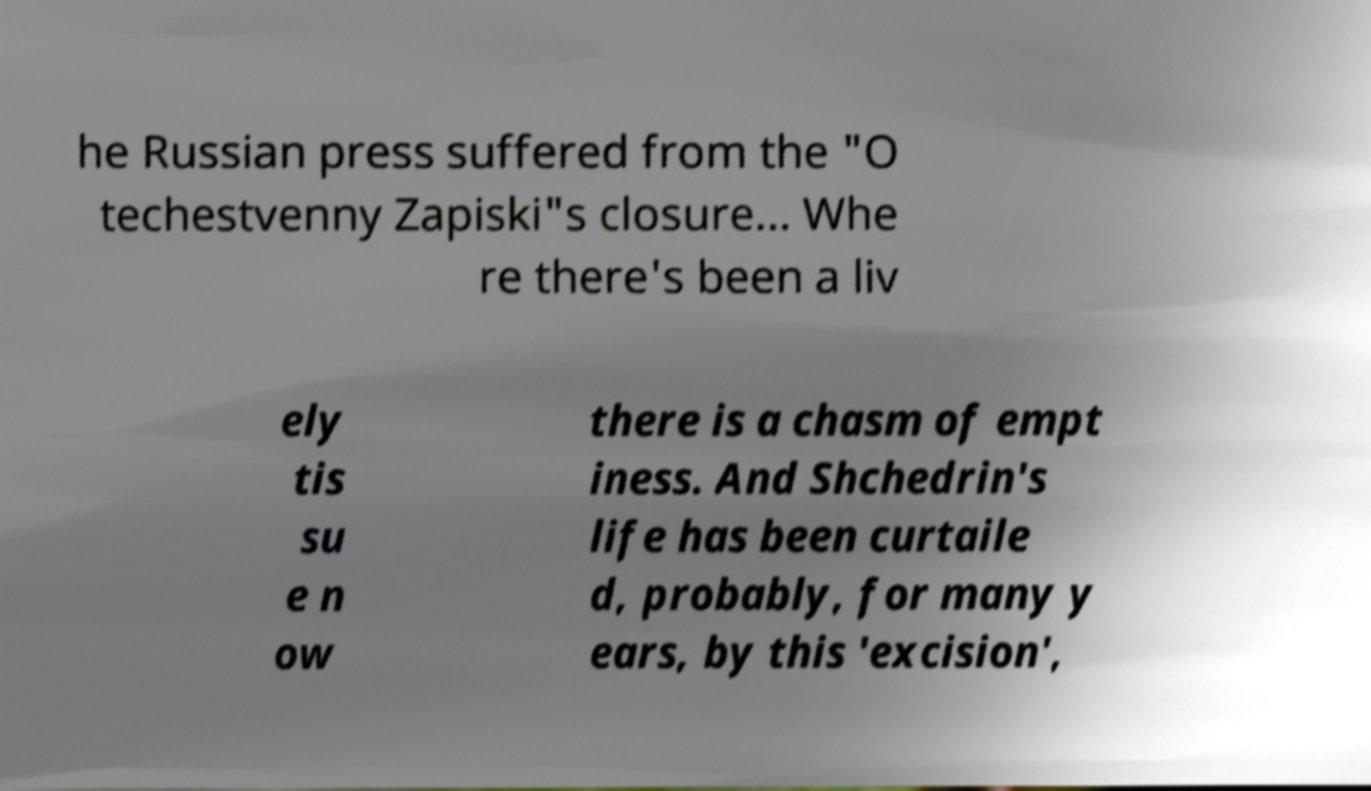For documentation purposes, I need the text within this image transcribed. Could you provide that? he Russian press suffered from the "O techestvenny Zapiski"s closure… Whe re there's been a liv ely tis su e n ow there is a chasm of empt iness. And Shchedrin's life has been curtaile d, probably, for many y ears, by this 'excision', 